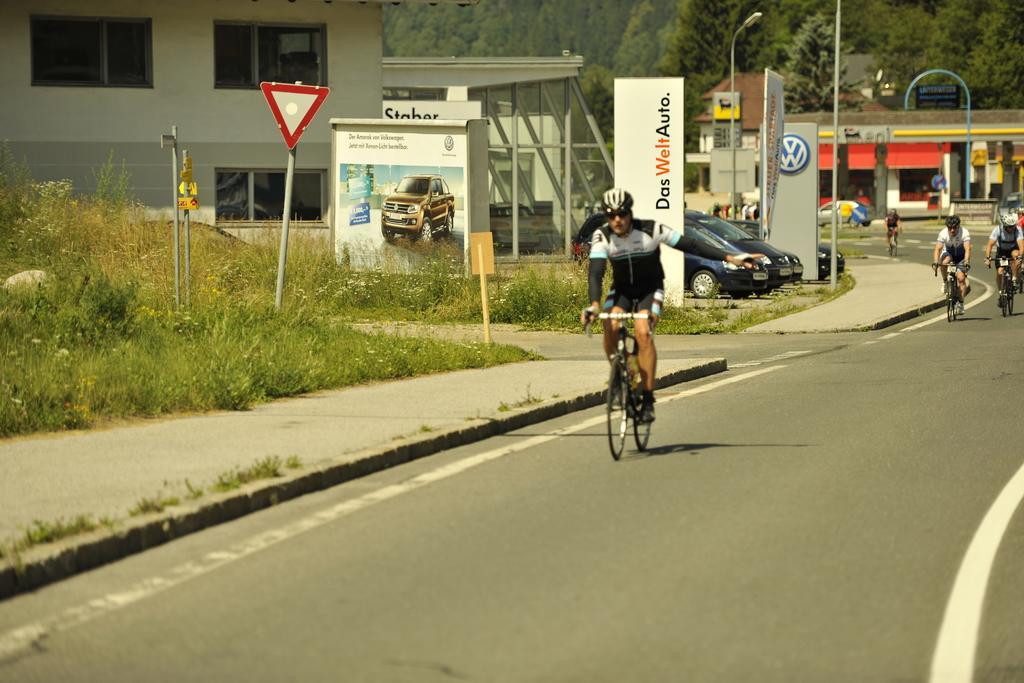Describe this image in one or two sentences. In this image, I can see few people riding bicycles on the road. There are plants, boards, buildings and vehicles, which are parked. In the background, there are trees. 